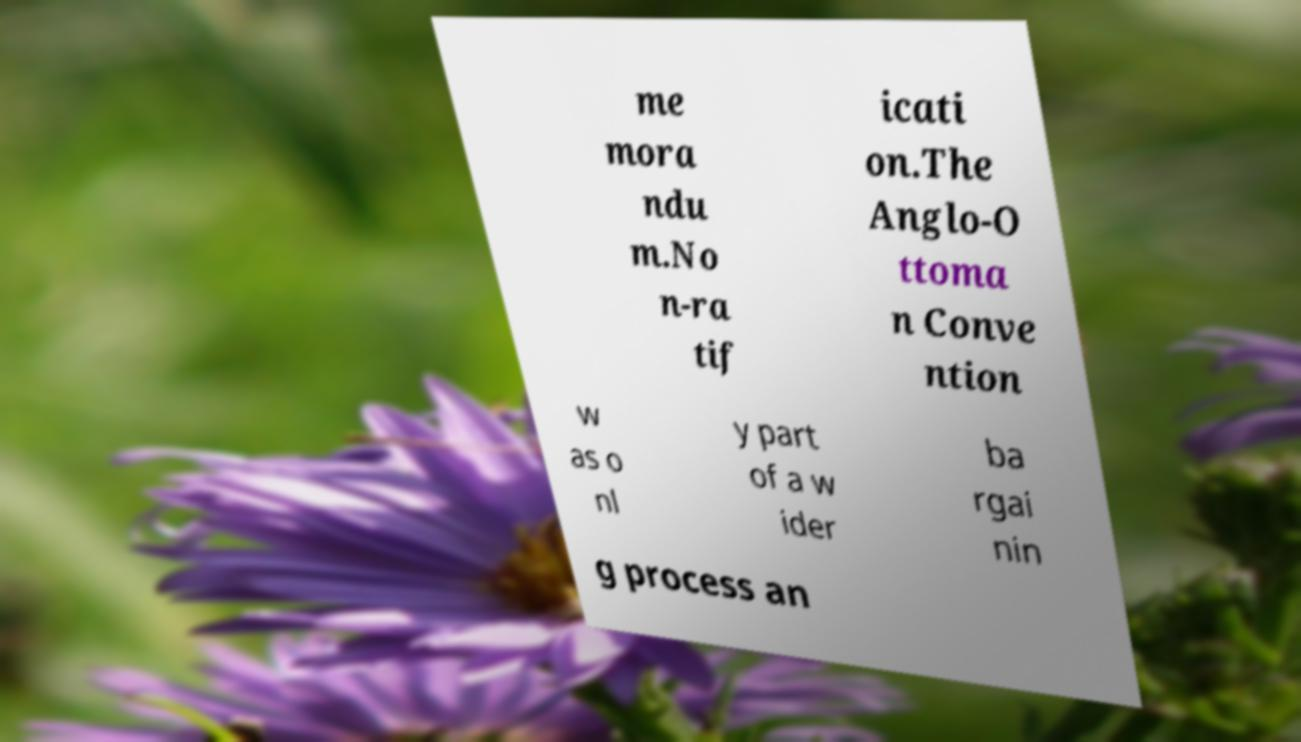For documentation purposes, I need the text within this image transcribed. Could you provide that? me mora ndu m.No n-ra tif icati on.The Anglo-O ttoma n Conve ntion w as o nl y part of a w ider ba rgai nin g process an 